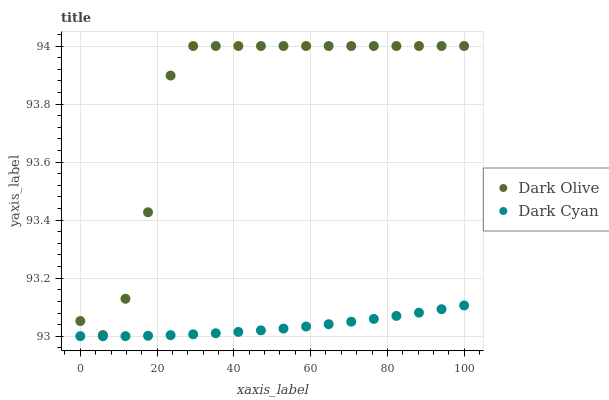Does Dark Cyan have the minimum area under the curve?
Answer yes or no. Yes. Does Dark Olive have the maximum area under the curve?
Answer yes or no. Yes. Does Dark Olive have the minimum area under the curve?
Answer yes or no. No. Is Dark Cyan the smoothest?
Answer yes or no. Yes. Is Dark Olive the roughest?
Answer yes or no. Yes. Is Dark Olive the smoothest?
Answer yes or no. No. Does Dark Cyan have the lowest value?
Answer yes or no. Yes. Does Dark Olive have the lowest value?
Answer yes or no. No. Does Dark Olive have the highest value?
Answer yes or no. Yes. Is Dark Cyan less than Dark Olive?
Answer yes or no. Yes. Is Dark Olive greater than Dark Cyan?
Answer yes or no. Yes. Does Dark Cyan intersect Dark Olive?
Answer yes or no. No. 